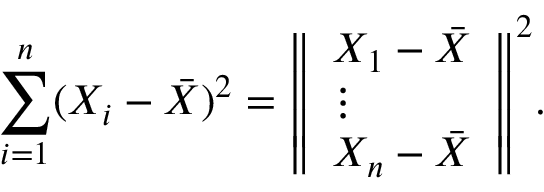Convert formula to latex. <formula><loc_0><loc_0><loc_500><loc_500>\sum _ { i = 1 } ^ { n } ( X _ { i } - { \bar { X } } ) ^ { 2 } = { \left \| \begin{array} { l } { X _ { 1 } - { \bar { X } } } \\ { \vdots } \\ { X _ { n } - { \bar { X } } } \end{array} \right \| } ^ { 2 } .</formula> 